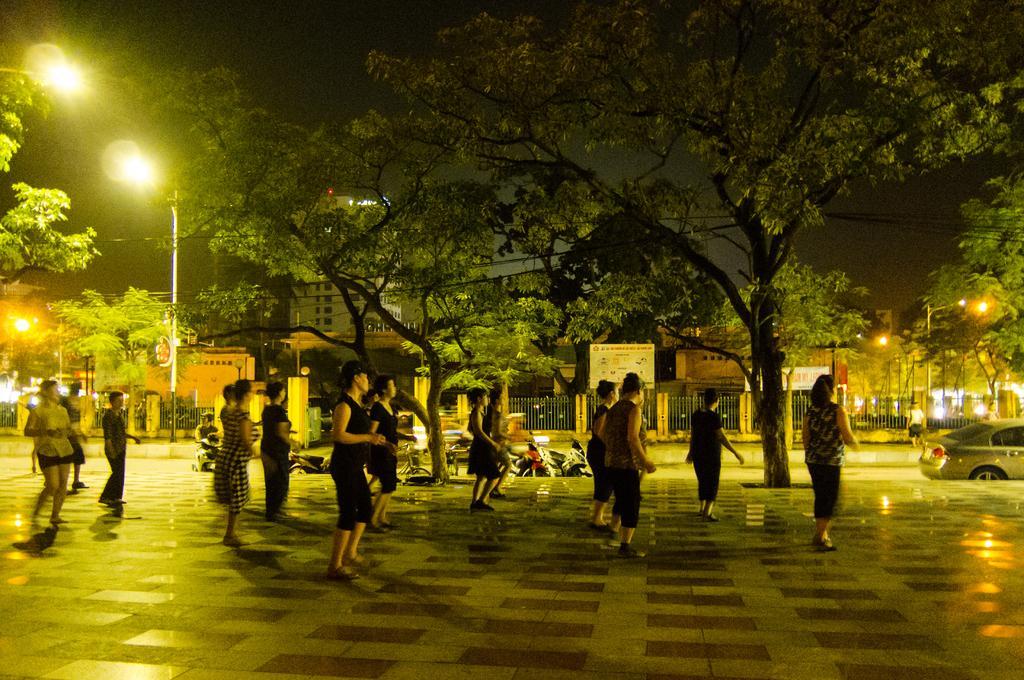Can you describe this image briefly? In this image we can see few persons are in motion on the floor. In the background there are trees, poles, street lights, vehicles on the road, fence, buildings, hoardings, few persons and sky. 